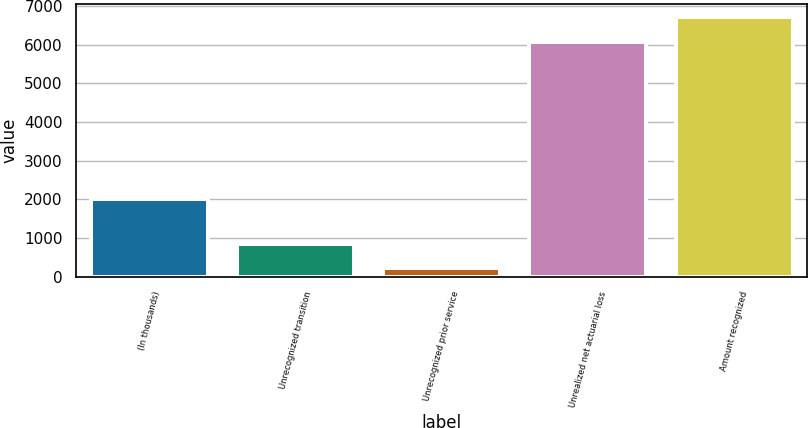Convert chart. <chart><loc_0><loc_0><loc_500><loc_500><bar_chart><fcel>(In thousands)<fcel>Unrecognized transition<fcel>Unrecognized prior service<fcel>Unrealized net actuarial loss<fcel>Amount recognized<nl><fcel>2008<fcel>862.2<fcel>223<fcel>6068<fcel>6707.2<nl></chart> 